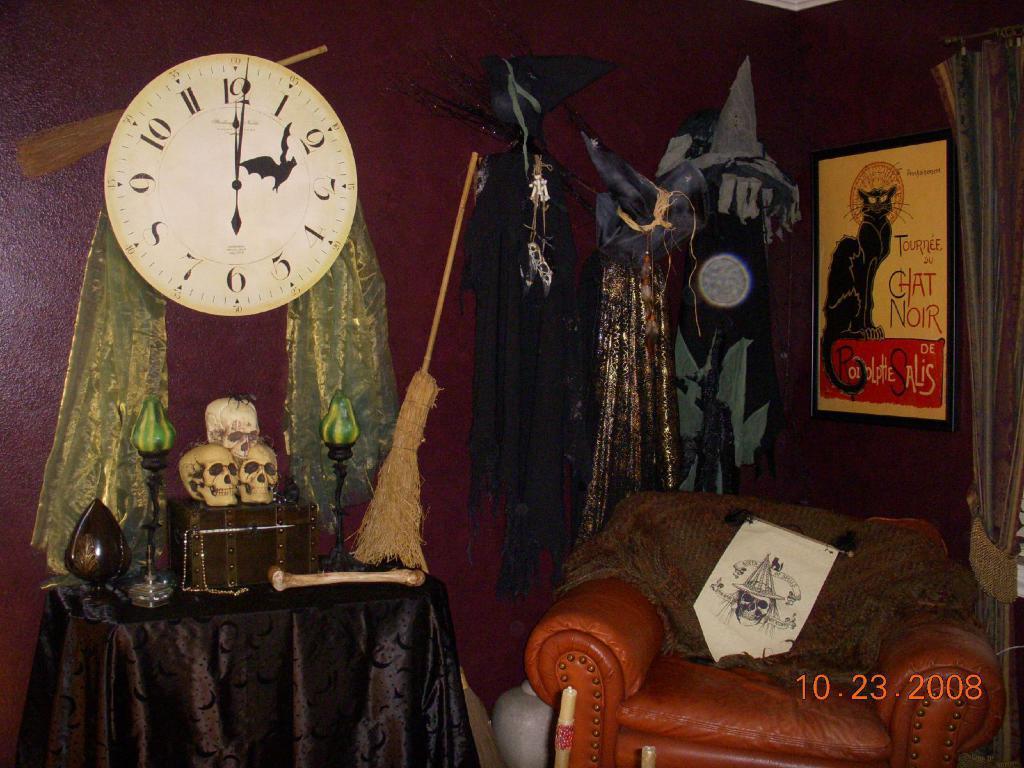How would you summarize this image in a sentence or two? In this picture we can observe a wall clock fixed to the maroon color wall. We can observe a broomstick. There are three skulls placed on this box on the table. We can observe a sofa. There are some costumes hanged to the wall. We can observe photo frames fixed to the wall. In the right side there is a curtain. 